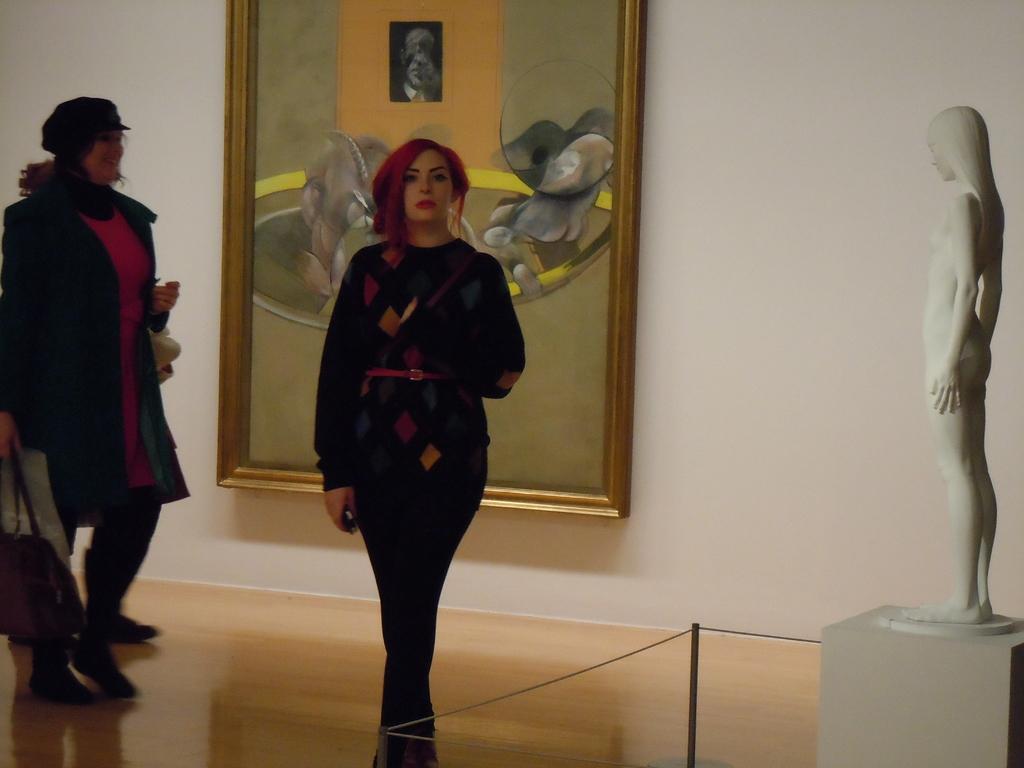In one or two sentences, can you explain what this image depicts? In the foreground of this picture, there is a woman in black dress walking on the floor. There is a sculpture on the right side of the image. There is another woman walking on the floor is on the left side of the image. There is a photo frame in the background. 